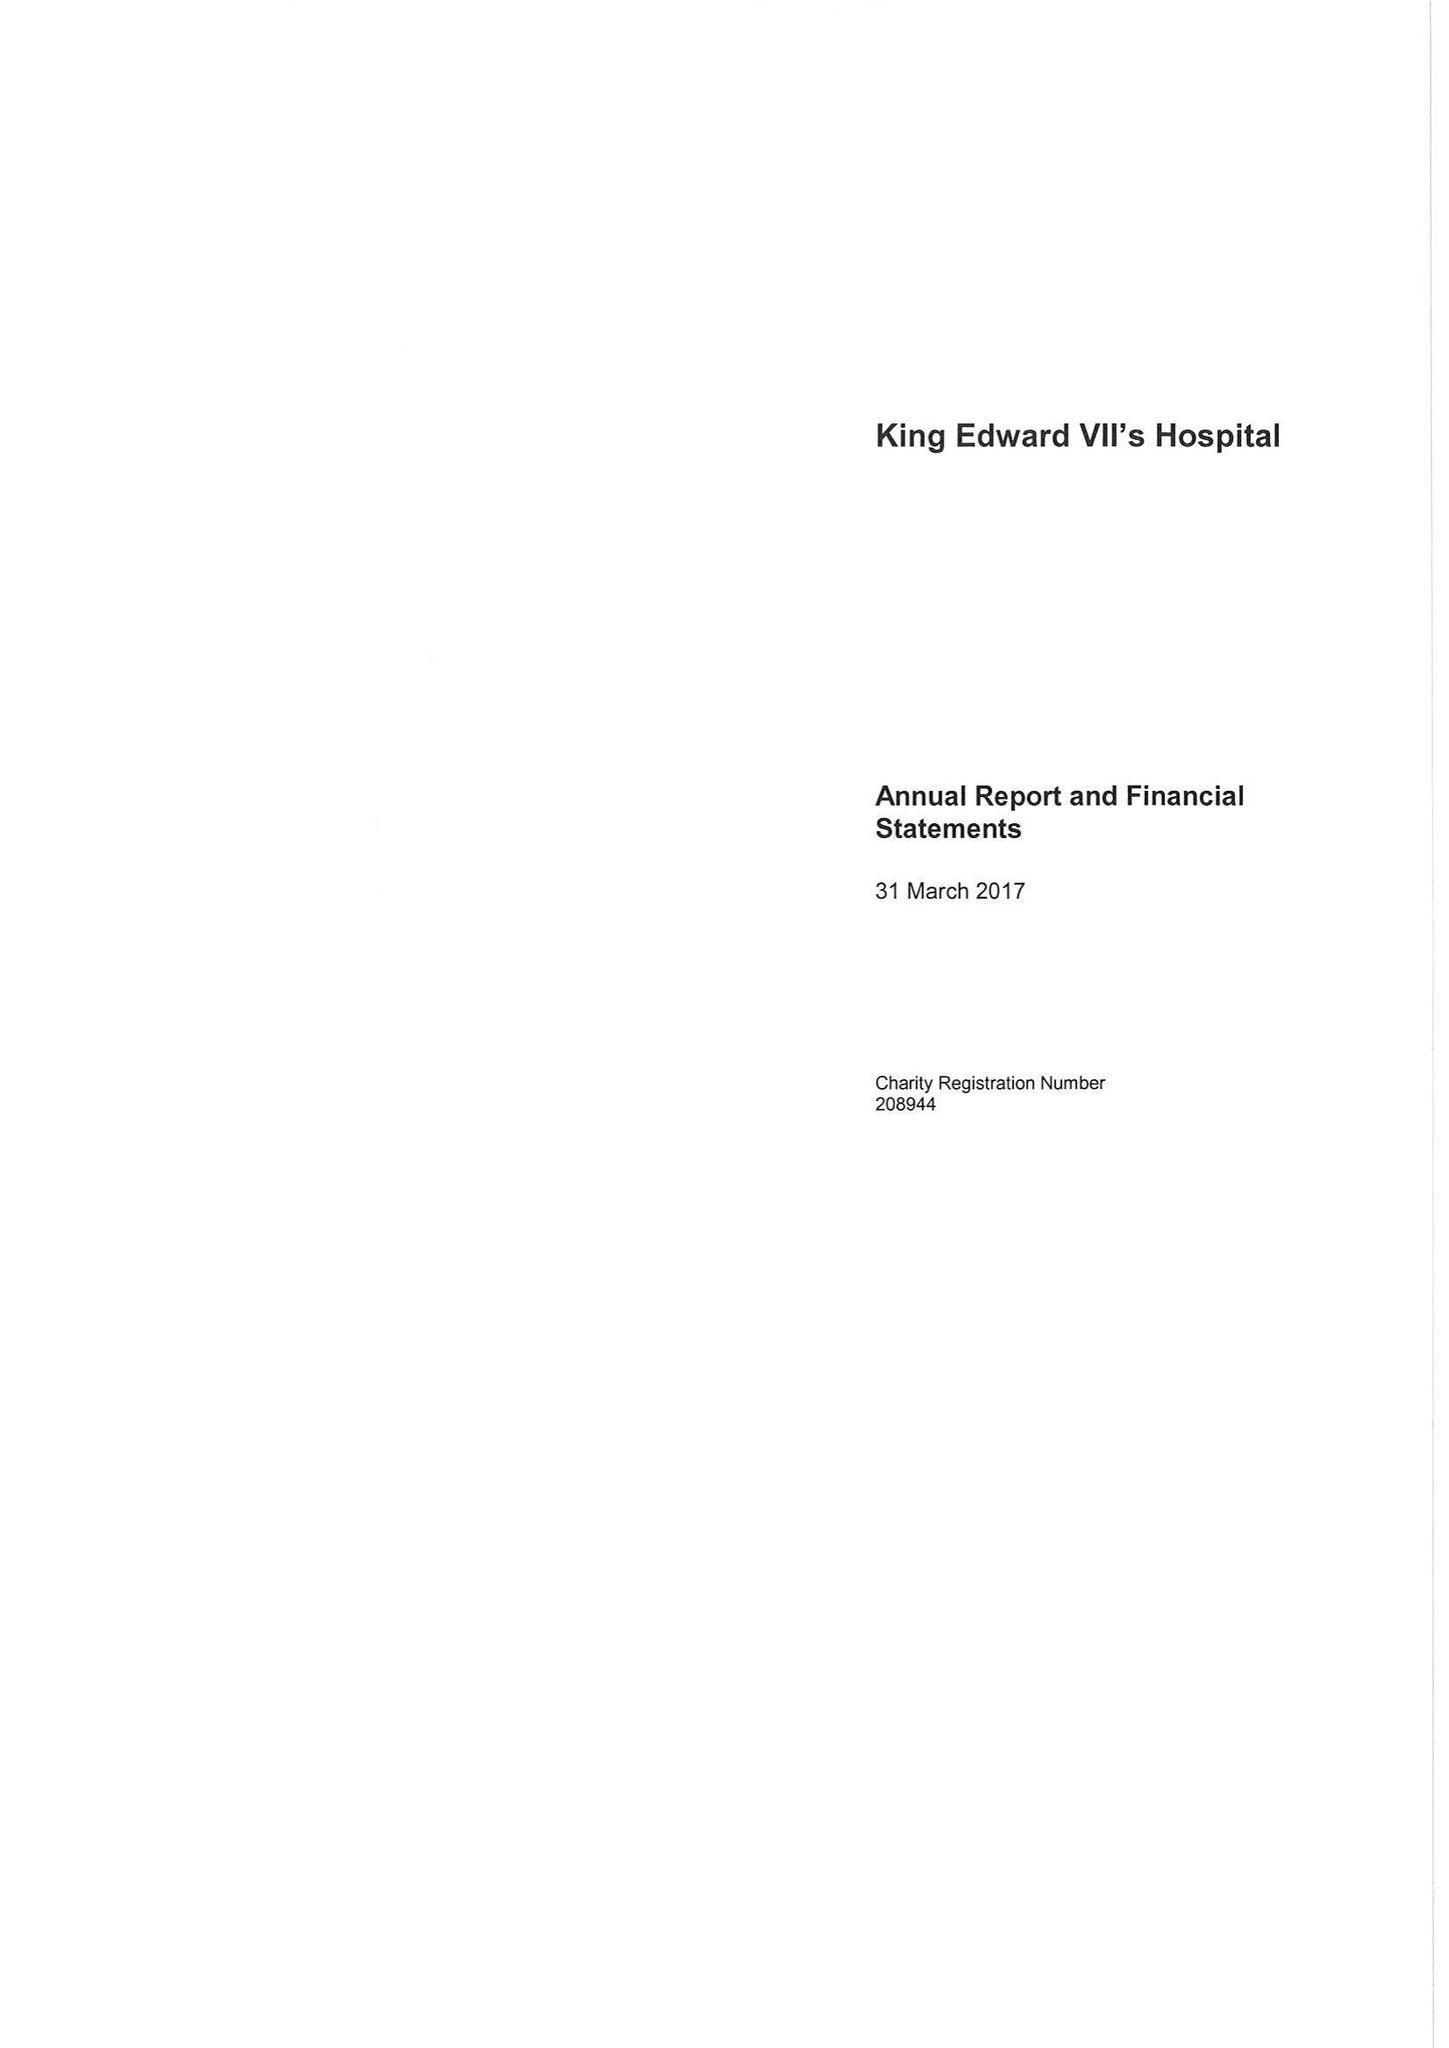What is the value for the address__post_town?
Answer the question using a single word or phrase. LONDON 